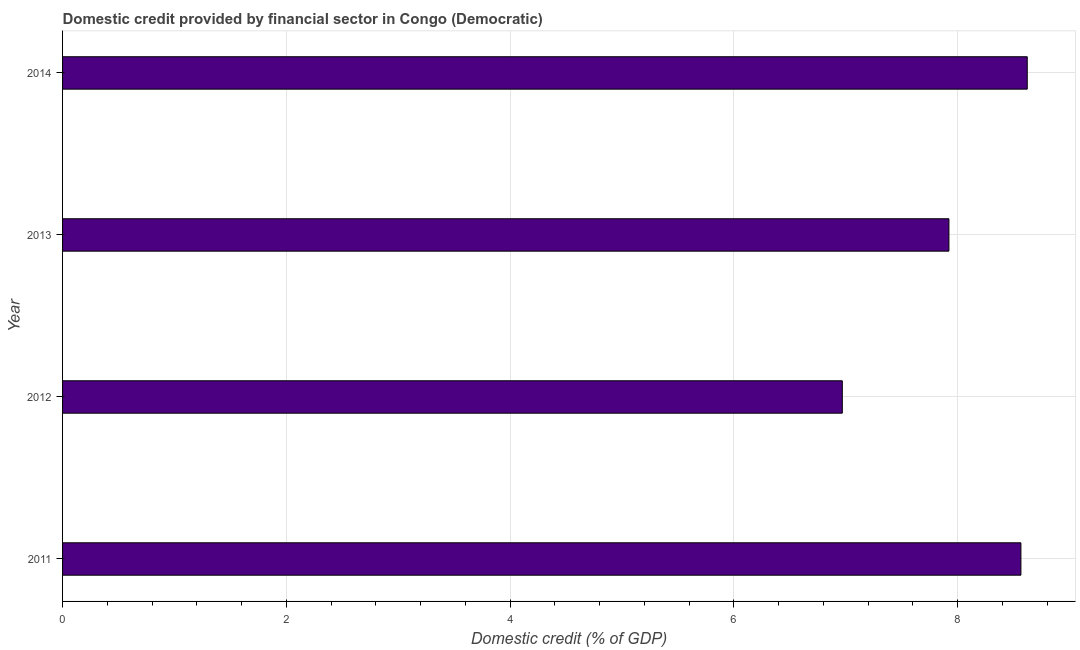What is the title of the graph?
Provide a short and direct response. Domestic credit provided by financial sector in Congo (Democratic). What is the label or title of the X-axis?
Make the answer very short. Domestic credit (% of GDP). What is the domestic credit provided by financial sector in 2012?
Give a very brief answer. 6.97. Across all years, what is the maximum domestic credit provided by financial sector?
Provide a short and direct response. 8.62. Across all years, what is the minimum domestic credit provided by financial sector?
Provide a succinct answer. 6.97. In which year was the domestic credit provided by financial sector maximum?
Offer a very short reply. 2014. In which year was the domestic credit provided by financial sector minimum?
Your answer should be very brief. 2012. What is the sum of the domestic credit provided by financial sector?
Keep it short and to the point. 32.07. What is the difference between the domestic credit provided by financial sector in 2012 and 2014?
Your response must be concise. -1.65. What is the average domestic credit provided by financial sector per year?
Your answer should be compact. 8.02. What is the median domestic credit provided by financial sector?
Your response must be concise. 8.24. What is the ratio of the domestic credit provided by financial sector in 2011 to that in 2013?
Give a very brief answer. 1.08. Is the domestic credit provided by financial sector in 2011 less than that in 2013?
Give a very brief answer. No. Is the difference between the domestic credit provided by financial sector in 2012 and 2013 greater than the difference between any two years?
Provide a succinct answer. No. What is the difference between the highest and the second highest domestic credit provided by financial sector?
Make the answer very short. 0.06. Is the sum of the domestic credit provided by financial sector in 2012 and 2014 greater than the maximum domestic credit provided by financial sector across all years?
Your answer should be very brief. Yes. What is the difference between the highest and the lowest domestic credit provided by financial sector?
Ensure brevity in your answer.  1.65. Are all the bars in the graph horizontal?
Ensure brevity in your answer.  Yes. Are the values on the major ticks of X-axis written in scientific E-notation?
Provide a short and direct response. No. What is the Domestic credit (% of GDP) of 2011?
Your answer should be very brief. 8.56. What is the Domestic credit (% of GDP) of 2012?
Your answer should be compact. 6.97. What is the Domestic credit (% of GDP) of 2013?
Your answer should be compact. 7.92. What is the Domestic credit (% of GDP) in 2014?
Offer a terse response. 8.62. What is the difference between the Domestic credit (% of GDP) in 2011 and 2012?
Keep it short and to the point. 1.6. What is the difference between the Domestic credit (% of GDP) in 2011 and 2013?
Offer a terse response. 0.64. What is the difference between the Domestic credit (% of GDP) in 2011 and 2014?
Provide a short and direct response. -0.06. What is the difference between the Domestic credit (% of GDP) in 2012 and 2013?
Your answer should be compact. -0.95. What is the difference between the Domestic credit (% of GDP) in 2012 and 2014?
Your answer should be very brief. -1.65. What is the difference between the Domestic credit (% of GDP) in 2013 and 2014?
Your response must be concise. -0.7. What is the ratio of the Domestic credit (% of GDP) in 2011 to that in 2012?
Ensure brevity in your answer.  1.23. What is the ratio of the Domestic credit (% of GDP) in 2011 to that in 2013?
Ensure brevity in your answer.  1.08. What is the ratio of the Domestic credit (% of GDP) in 2011 to that in 2014?
Make the answer very short. 0.99. What is the ratio of the Domestic credit (% of GDP) in 2012 to that in 2013?
Give a very brief answer. 0.88. What is the ratio of the Domestic credit (% of GDP) in 2012 to that in 2014?
Make the answer very short. 0.81. What is the ratio of the Domestic credit (% of GDP) in 2013 to that in 2014?
Provide a succinct answer. 0.92. 